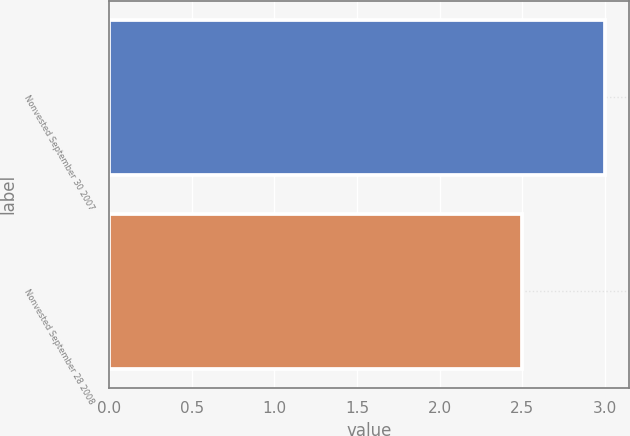Convert chart. <chart><loc_0><loc_0><loc_500><loc_500><bar_chart><fcel>Nonvested September 30 2007<fcel>Nonvested September 28 2008<nl><fcel>3<fcel>2.5<nl></chart> 